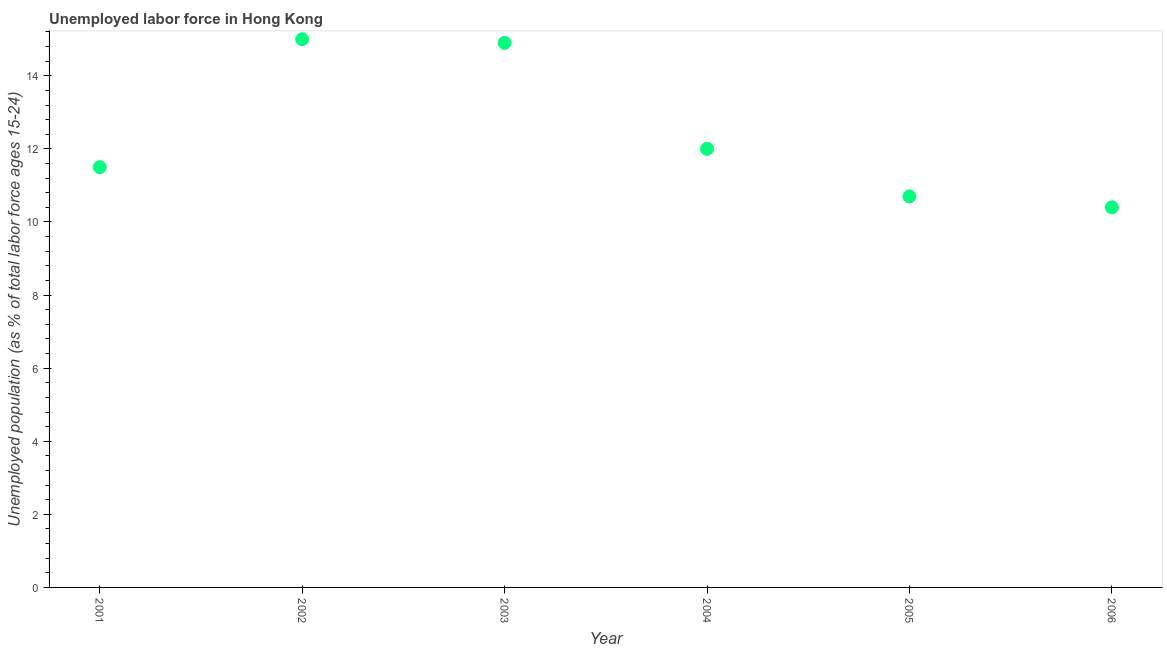What is the total unemployed youth population in 2005?
Your answer should be very brief. 10.7. Across all years, what is the maximum total unemployed youth population?
Keep it short and to the point. 15. Across all years, what is the minimum total unemployed youth population?
Give a very brief answer. 10.4. In which year was the total unemployed youth population minimum?
Provide a short and direct response. 2006. What is the sum of the total unemployed youth population?
Provide a succinct answer. 74.5. What is the difference between the total unemployed youth population in 2001 and 2005?
Ensure brevity in your answer.  0.8. What is the average total unemployed youth population per year?
Ensure brevity in your answer.  12.42. What is the median total unemployed youth population?
Give a very brief answer. 11.75. In how many years, is the total unemployed youth population greater than 6 %?
Give a very brief answer. 6. Do a majority of the years between 2005 and 2002 (inclusive) have total unemployed youth population greater than 3.2 %?
Your answer should be very brief. Yes. What is the ratio of the total unemployed youth population in 2003 to that in 2006?
Ensure brevity in your answer.  1.43. Is the total unemployed youth population in 2004 less than that in 2006?
Make the answer very short. No. Is the difference between the total unemployed youth population in 2004 and 2006 greater than the difference between any two years?
Offer a terse response. No. What is the difference between the highest and the second highest total unemployed youth population?
Your response must be concise. 0.1. Is the sum of the total unemployed youth population in 2001 and 2002 greater than the maximum total unemployed youth population across all years?
Ensure brevity in your answer.  Yes. What is the difference between the highest and the lowest total unemployed youth population?
Ensure brevity in your answer.  4.6. How many dotlines are there?
Offer a terse response. 1. Are the values on the major ticks of Y-axis written in scientific E-notation?
Ensure brevity in your answer.  No. Does the graph contain any zero values?
Ensure brevity in your answer.  No. Does the graph contain grids?
Give a very brief answer. No. What is the title of the graph?
Provide a succinct answer. Unemployed labor force in Hong Kong. What is the label or title of the Y-axis?
Ensure brevity in your answer.  Unemployed population (as % of total labor force ages 15-24). What is the Unemployed population (as % of total labor force ages 15-24) in 2001?
Offer a very short reply. 11.5. What is the Unemployed population (as % of total labor force ages 15-24) in 2003?
Your answer should be very brief. 14.9. What is the Unemployed population (as % of total labor force ages 15-24) in 2005?
Your answer should be compact. 10.7. What is the Unemployed population (as % of total labor force ages 15-24) in 2006?
Provide a succinct answer. 10.4. What is the difference between the Unemployed population (as % of total labor force ages 15-24) in 2003 and 2004?
Your answer should be very brief. 2.9. What is the difference between the Unemployed population (as % of total labor force ages 15-24) in 2003 and 2005?
Keep it short and to the point. 4.2. What is the difference between the Unemployed population (as % of total labor force ages 15-24) in 2004 and 2005?
Offer a very short reply. 1.3. What is the difference between the Unemployed population (as % of total labor force ages 15-24) in 2004 and 2006?
Provide a succinct answer. 1.6. What is the difference between the Unemployed population (as % of total labor force ages 15-24) in 2005 and 2006?
Ensure brevity in your answer.  0.3. What is the ratio of the Unemployed population (as % of total labor force ages 15-24) in 2001 to that in 2002?
Provide a short and direct response. 0.77. What is the ratio of the Unemployed population (as % of total labor force ages 15-24) in 2001 to that in 2003?
Provide a short and direct response. 0.77. What is the ratio of the Unemployed population (as % of total labor force ages 15-24) in 2001 to that in 2004?
Ensure brevity in your answer.  0.96. What is the ratio of the Unemployed population (as % of total labor force ages 15-24) in 2001 to that in 2005?
Make the answer very short. 1.07. What is the ratio of the Unemployed population (as % of total labor force ages 15-24) in 2001 to that in 2006?
Provide a short and direct response. 1.11. What is the ratio of the Unemployed population (as % of total labor force ages 15-24) in 2002 to that in 2003?
Make the answer very short. 1.01. What is the ratio of the Unemployed population (as % of total labor force ages 15-24) in 2002 to that in 2005?
Your answer should be very brief. 1.4. What is the ratio of the Unemployed population (as % of total labor force ages 15-24) in 2002 to that in 2006?
Make the answer very short. 1.44. What is the ratio of the Unemployed population (as % of total labor force ages 15-24) in 2003 to that in 2004?
Offer a terse response. 1.24. What is the ratio of the Unemployed population (as % of total labor force ages 15-24) in 2003 to that in 2005?
Ensure brevity in your answer.  1.39. What is the ratio of the Unemployed population (as % of total labor force ages 15-24) in 2003 to that in 2006?
Keep it short and to the point. 1.43. What is the ratio of the Unemployed population (as % of total labor force ages 15-24) in 2004 to that in 2005?
Make the answer very short. 1.12. What is the ratio of the Unemployed population (as % of total labor force ages 15-24) in 2004 to that in 2006?
Your response must be concise. 1.15. What is the ratio of the Unemployed population (as % of total labor force ages 15-24) in 2005 to that in 2006?
Ensure brevity in your answer.  1.03. 